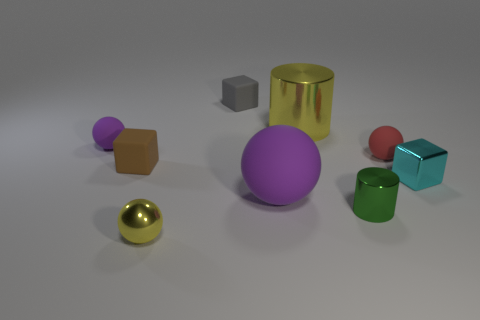Are there fewer purple things that are to the left of the big yellow metal object than yellow spheres?
Offer a very short reply. No. What is the shape of the brown rubber object that is the same size as the red sphere?
Offer a very short reply. Cube. What number of other objects are the same color as the metallic block?
Make the answer very short. 0. Is the yellow shiny cylinder the same size as the green object?
Your response must be concise. No. How many things are brown rubber objects or large objects that are right of the large purple rubber object?
Make the answer very short. 2. Are there fewer yellow cylinders that are on the left side of the big purple rubber ball than rubber things left of the gray rubber object?
Provide a short and direct response. Yes. How many other things are there of the same material as the small red thing?
Offer a terse response. 4. Does the rubber block that is on the left side of the tiny gray rubber block have the same color as the metallic ball?
Provide a succinct answer. No. Are there any large cylinders in front of the block that is right of the small green metal thing?
Offer a very short reply. No. The cube that is both on the left side of the large yellow metal thing and in front of the gray thing is made of what material?
Keep it short and to the point. Rubber. 